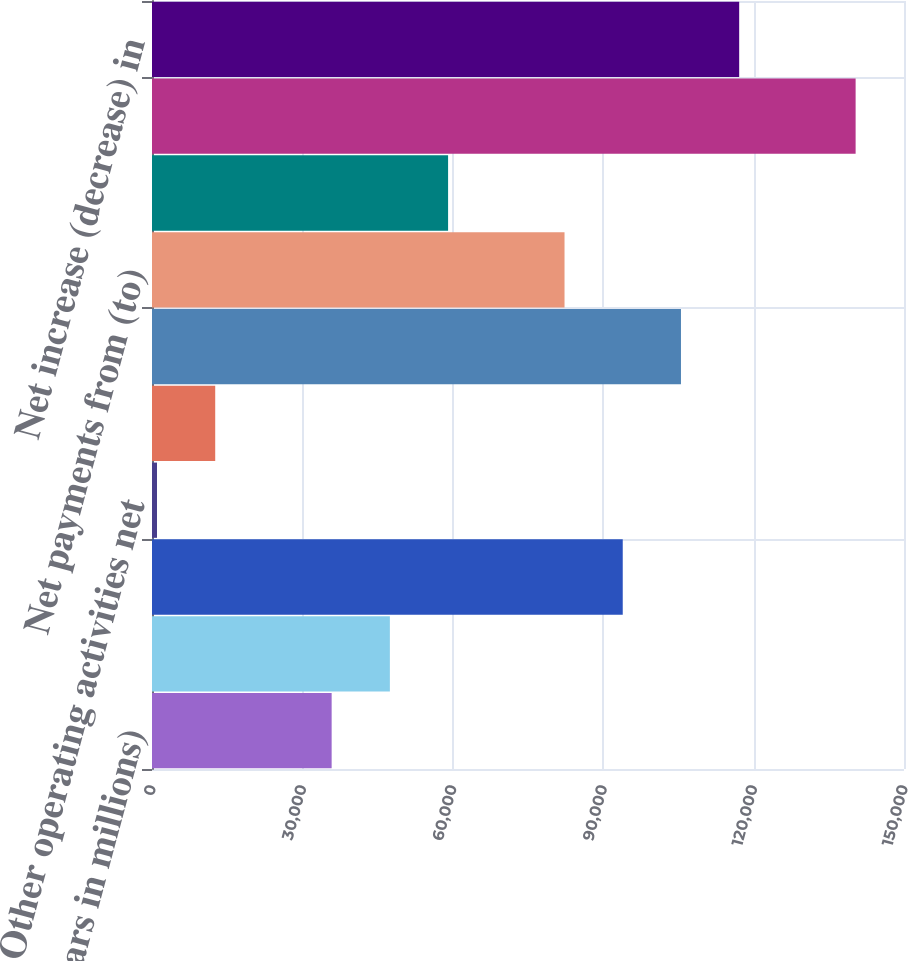Convert chart. <chart><loc_0><loc_0><loc_500><loc_500><bar_chart><fcel>(Dollars in millions)<fcel>Net income (loss)<fcel>Equity in undistributed<fcel>Other operating activities net<fcel>Net cash provided by operating<fcel>Net sales of securities<fcel>Net payments from (to)<fcel>Other investing activities net<fcel>Net cash provided by (used in)<fcel>Net increase (decrease) in<nl><fcel>35834.4<fcel>47447.2<fcel>93898.4<fcel>996<fcel>12608.8<fcel>105511<fcel>82285.6<fcel>59060<fcel>140350<fcel>117124<nl></chart> 